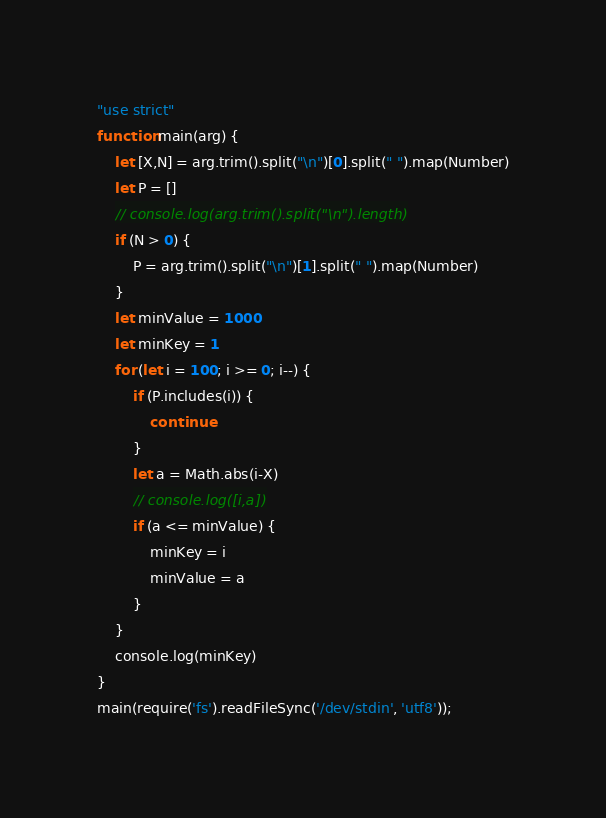Convert code to text. <code><loc_0><loc_0><loc_500><loc_500><_JavaScript_>"use strict"
function main(arg) {
    let [X,N] = arg.trim().split("\n")[0].split(" ").map(Number)
    let P = []
    // console.log(arg.trim().split("\n").length)
    if (N > 0) {
        P = arg.trim().split("\n")[1].split(" ").map(Number)
    } 
    let minValue = 1000
    let minKey = 1
    for (let i = 100; i >= 0; i--) {
        if (P.includes(i)) {
            continue
        }
        let a = Math.abs(i-X)
        // console.log([i,a])
        if (a <= minValue) {
            minKey = i
            minValue = a
        }
    }
    console.log(minKey)
}
main(require('fs').readFileSync('/dev/stdin', 'utf8'));</code> 